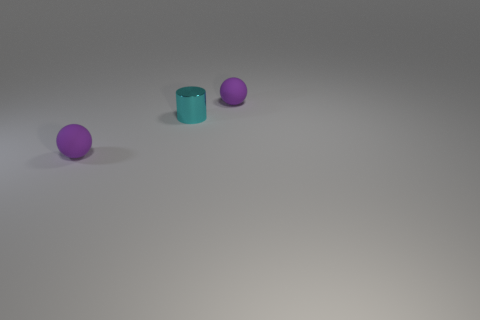There is a purple thing that is in front of the tiny purple matte ball behind the tiny cyan cylinder; is there a small cylinder that is in front of it?
Your response must be concise. No. Are there any other things that are made of the same material as the cyan cylinder?
Offer a very short reply. No. Are any small yellow spheres visible?
Give a very brief answer. No. There is a cylinder left of the matte object behind the purple sphere that is on the left side of the tiny cyan object; what size is it?
Provide a succinct answer. Small. How many tiny rubber objects are the same color as the cylinder?
Provide a succinct answer. 0. How many objects are big green rubber spheres or small purple spheres that are behind the tiny metal object?
Ensure brevity in your answer.  1. The metal object is what color?
Provide a short and direct response. Cyan. There is a tiny ball left of the tiny cyan metallic thing; what color is it?
Make the answer very short. Purple. There is a small purple matte thing on the right side of the small cyan metallic cylinder; what number of tiny cyan metal cylinders are behind it?
Ensure brevity in your answer.  0. There is a cyan object; is it the same size as the purple rubber sphere that is behind the tiny cylinder?
Offer a terse response. Yes. 